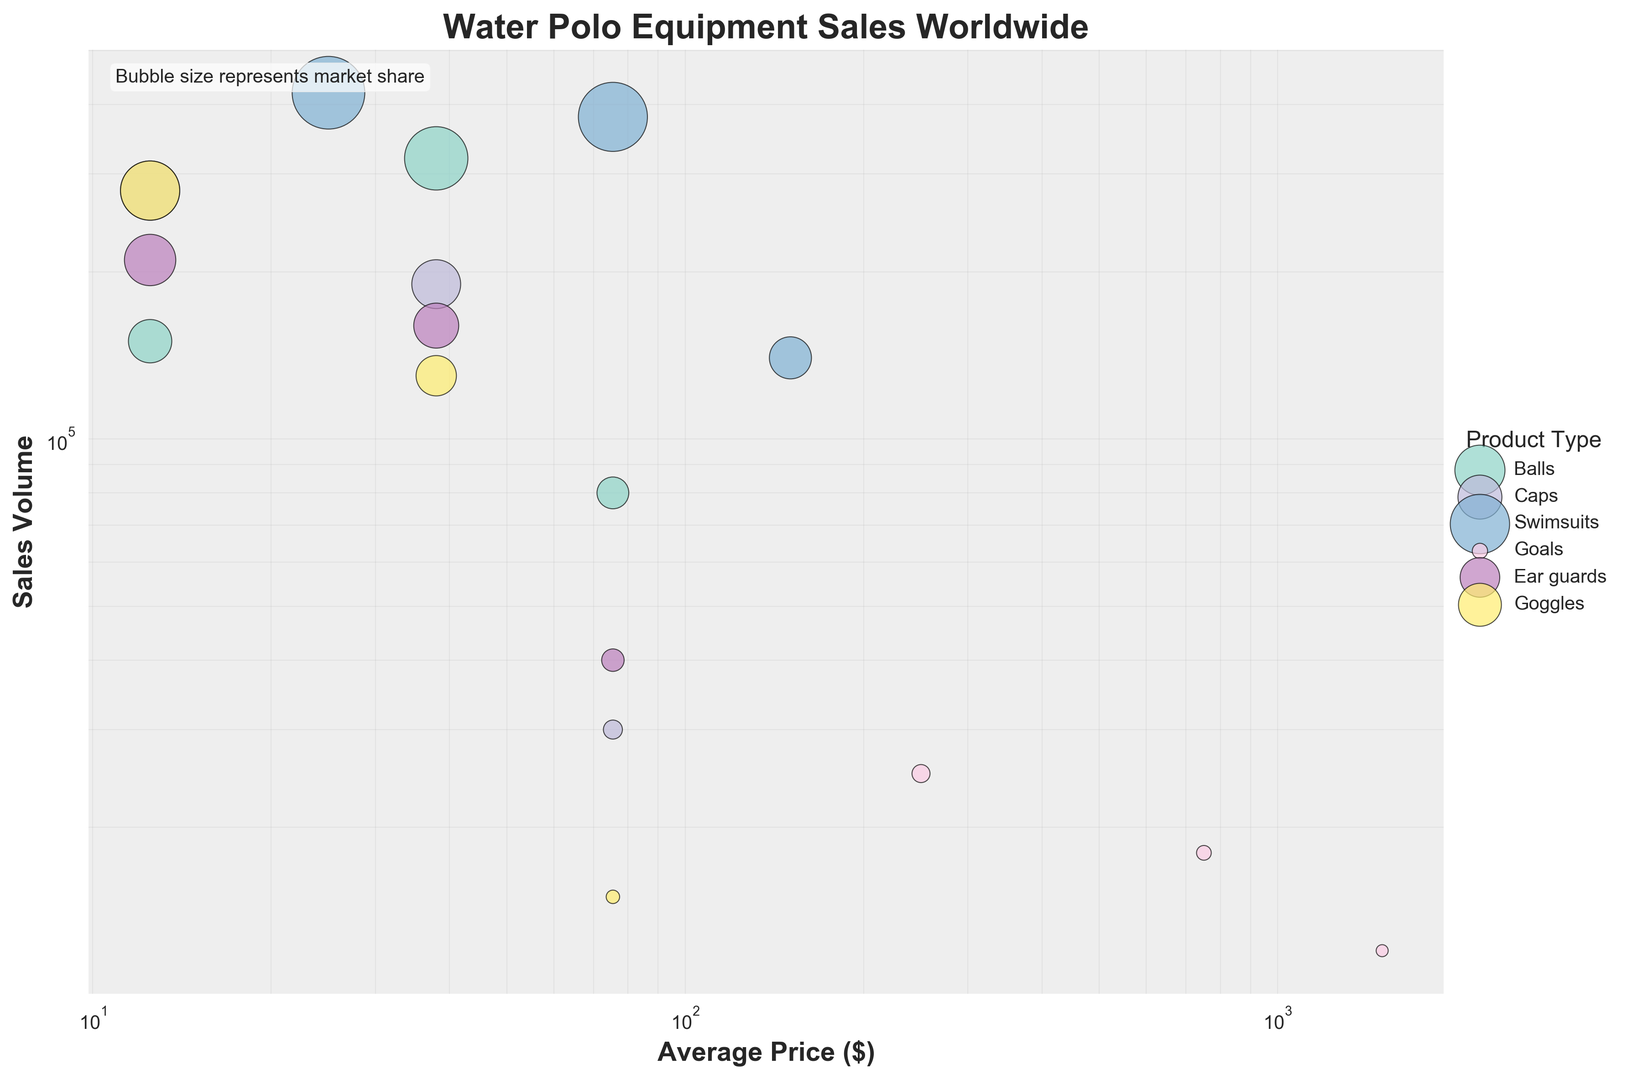What product type has the highest sales volume in the 0-25 price range? In the 0-25 price range, the highest bubble size and sales volume correspond to the product "Swimsuits" with a sales volume of 420,000.
Answer: Swimsuits What is the average price range of the Caps product type with the highest sales volume? The Caps in the 0-25 price range has the highest sales volume of 280,000. The average price range of 0-25 is (0+25)/2 = 12.5.
Answer: 12.5 Which product type has the smallest market share for the price range of 51-100? The smallest bubble size in the 51-100 price range shows that "Goggles" have the smallest market share, with a value of 0.5.
Answer: Goggles What product type and price range combination have the highest market share? The largest bubble size represents the highest market share among all product types and price ranges, indicating "Swimsuits" in the price range of 0-50 have the highest market share at 14.6%.
Answer: Swimsuits at 0-50 How does the sales volume of Goals in the 1001-2000 price range compare to the sales volume of Balls in the 51-100 price range? Looking at the bubbles for Goals (1001-2000) and Balls (51-100), Goals have a sales volume of 12,000, whereas Balls have a sales volume of 80,000. Hence, the sales volume of Goals is lower.
Answer: Lower By how much does the market share of Swimsuits in the 0-50 price range exceed the market share of Caps in the 26-50 price range? Swimsuits have a market share of 14.6%, and Caps have a market share of 6.6%. The difference is 14.6 - 6.6 = 8.
Answer: 8% Which product type has the highest overall market share in the price range of 26-50? The largest bubble size in the 26-50 price range corresponds to "Balls" with a market share of 11.1%.
Answer: Balls How many product types have sales volumes exceeding 100,000 units in the price range of 26-50? "Balls," "Caps," "Swimsuits," and "Ear guards" all have sales volumes exceeding 100,000 units in the 26-50 price range, making it four product types.
Answer: Four What is the combined market share of Balls and Caps in all price ranges? Summing the market shares within respective ranges, Balls have 5.2 + 11.1 + 2.8 = 19.1%, and Caps have 9.7 + 6.6 + 1.0 = 17.3%. The combined market share for both is 19.1 + 17.3 = 36.4%.
Answer: 36.4% Which product type and price range represent the smallest bubble size on the chart? The smallest bubble size represents the "Goals" in the price range of 1001-2000, having a market share of 0.4%.
Answer: Goals at 1001-2000 